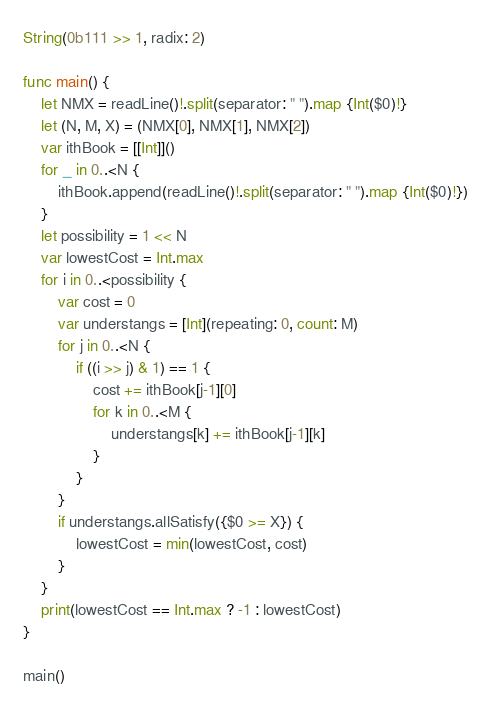<code> <loc_0><loc_0><loc_500><loc_500><_Swift_>String(0b111 >> 1, radix: 2)

func main() {
    let NMX = readLine()!.split(separator: " ").map {Int($0)!}
    let (N, M, X) = (NMX[0], NMX[1], NMX[2])
    var ithBook = [[Int]]()
    for _ in 0..<N {
        ithBook.append(readLine()!.split(separator: " ").map {Int($0)!})
    }
    let possibility = 1 << N
    var lowestCost = Int.max
    for i in 0..<possibility {
        var cost = 0
        var understangs = [Int](repeating: 0, count: M)
        for j in 0..<N {
            if ((i >> j) & 1) == 1 {
                cost += ithBook[j-1][0]
                for k in 0..<M {
                    understangs[k] += ithBook[j-1][k]
                }
            }
        }
        if understangs.allSatisfy({$0 >= X}) {
            lowestCost = min(lowestCost, cost)
        }
    }
    print(lowestCost == Int.max ? -1 : lowestCost)
}

main()
</code> 